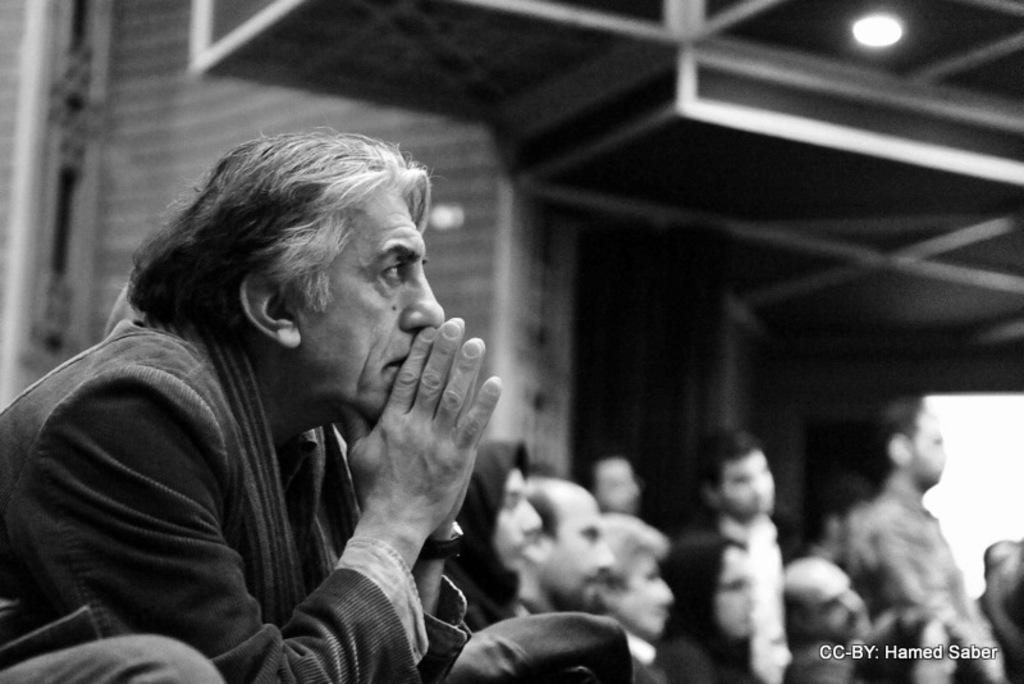What is the main subject in the foreground of the image? There is a man sitting in the foreground of the image. What is the color of the image? The image is black. How many people can be seen in the background of the image? There are few people in the background of the image. What type of structure is visible in the background of the image? There is a building in the background of the image. What is the source of light at the top in the background of the image? There is a light at the top in the background of the image. What type of tin can be seen holding a clam in the image? There is no tin or clam present in the image. 